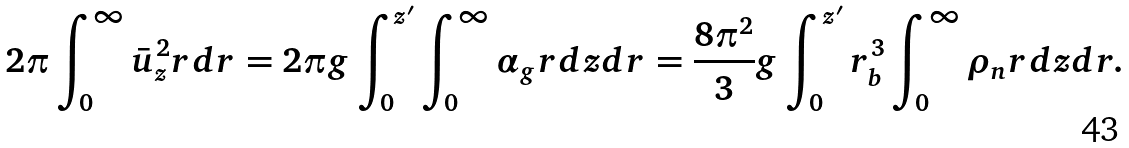Convert formula to latex. <formula><loc_0><loc_0><loc_500><loc_500>2 \pi \int _ { 0 } ^ { \infty } \bar { u } _ { z } ^ { 2 } r d r = 2 \pi g \int _ { 0 } ^ { z ^ { \prime } } \int _ { 0 } ^ { \infty } \alpha _ { g } r d z d r = \frac { 8 \pi ^ { 2 } } { 3 } g \int _ { 0 } ^ { z ^ { \prime } } r _ { b } ^ { 3 } \int _ { 0 } ^ { \infty } \rho _ { n } r d z d r .</formula> 